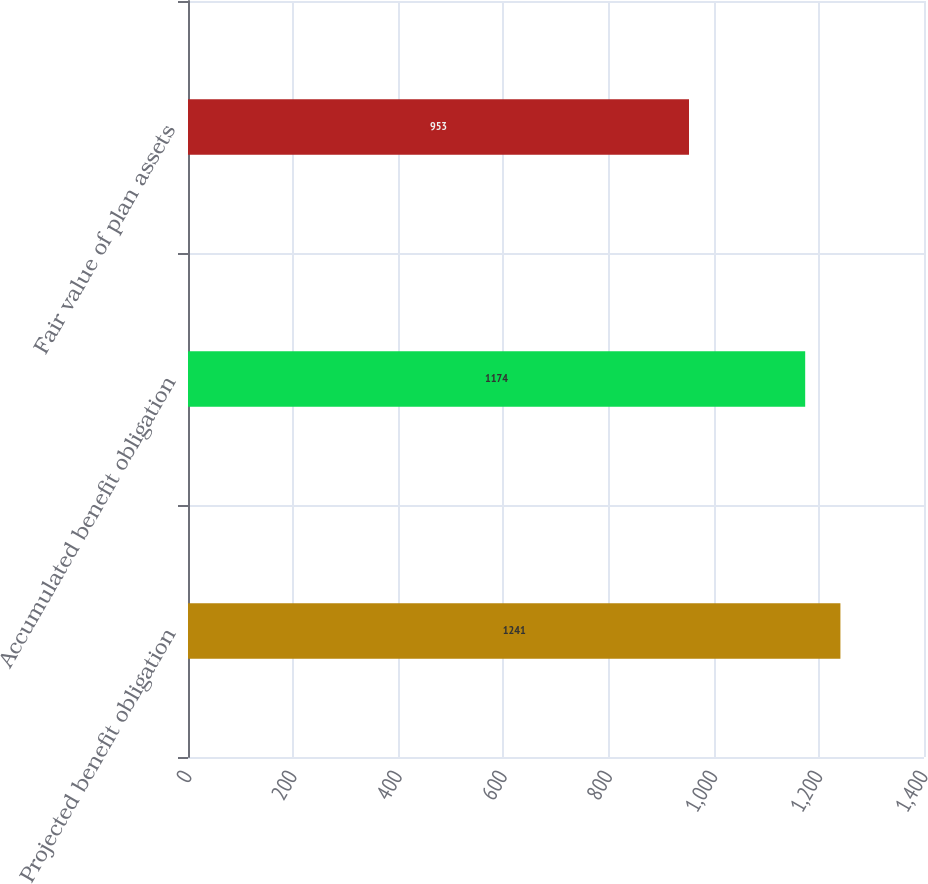<chart> <loc_0><loc_0><loc_500><loc_500><bar_chart><fcel>Projected benefit obligation<fcel>Accumulated benefit obligation<fcel>Fair value of plan assets<nl><fcel>1241<fcel>1174<fcel>953<nl></chart> 